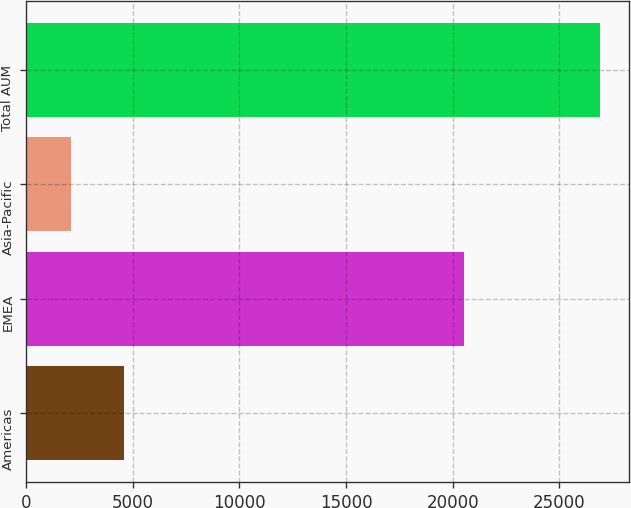<chart> <loc_0><loc_0><loc_500><loc_500><bar_chart><fcel>Americas<fcel>EMEA<fcel>Asia-Pacific<fcel>Total AUM<nl><fcel>4595.8<fcel>20536<fcel>2114<fcel>26932<nl></chart> 